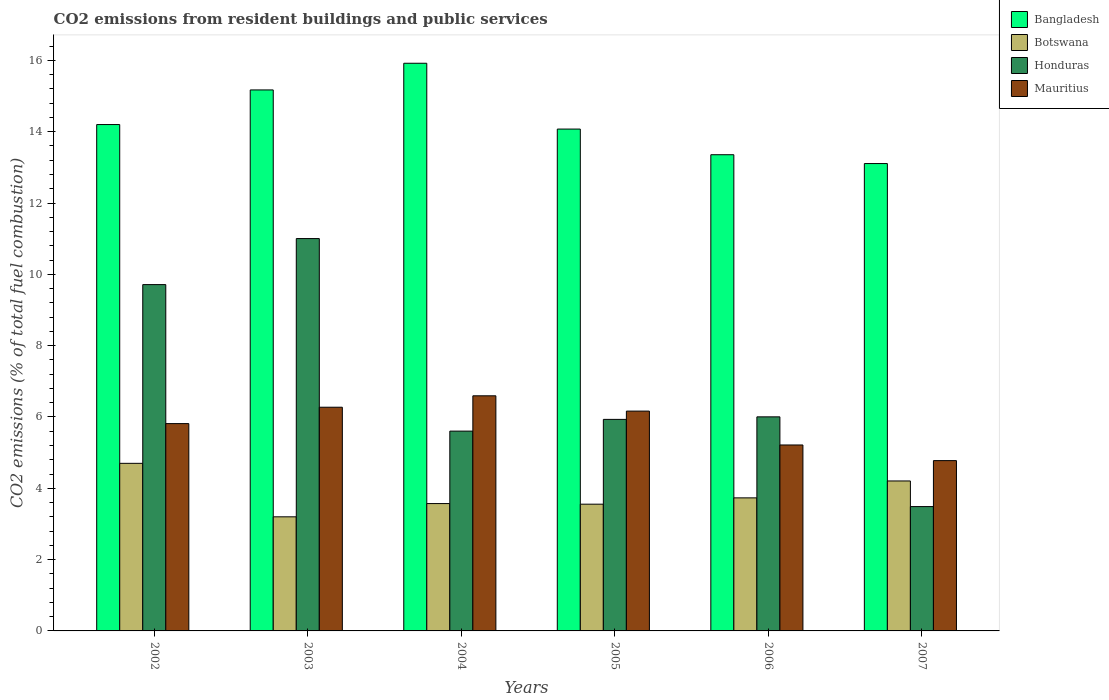How many different coloured bars are there?
Offer a very short reply. 4. How many groups of bars are there?
Provide a short and direct response. 6. How many bars are there on the 1st tick from the right?
Provide a succinct answer. 4. What is the label of the 4th group of bars from the left?
Keep it short and to the point. 2005. In how many cases, is the number of bars for a given year not equal to the number of legend labels?
Your response must be concise. 0. What is the total CO2 emitted in Mauritius in 2006?
Keep it short and to the point. 5.21. Across all years, what is the maximum total CO2 emitted in Mauritius?
Your answer should be compact. 6.59. Across all years, what is the minimum total CO2 emitted in Honduras?
Provide a short and direct response. 3.49. In which year was the total CO2 emitted in Bangladesh maximum?
Offer a very short reply. 2004. In which year was the total CO2 emitted in Botswana minimum?
Your answer should be compact. 2003. What is the total total CO2 emitted in Mauritius in the graph?
Make the answer very short. 34.84. What is the difference between the total CO2 emitted in Honduras in 2004 and that in 2007?
Offer a very short reply. 2.12. What is the difference between the total CO2 emitted in Mauritius in 2003 and the total CO2 emitted in Bangladesh in 2006?
Offer a very short reply. -7.08. What is the average total CO2 emitted in Botswana per year?
Your response must be concise. 3.83. In the year 2005, what is the difference between the total CO2 emitted in Mauritius and total CO2 emitted in Honduras?
Your answer should be very brief. 0.23. In how many years, is the total CO2 emitted in Botswana greater than 13.2?
Ensure brevity in your answer.  0. What is the ratio of the total CO2 emitted in Honduras in 2004 to that in 2005?
Provide a short and direct response. 0.94. Is the difference between the total CO2 emitted in Mauritius in 2004 and 2006 greater than the difference between the total CO2 emitted in Honduras in 2004 and 2006?
Provide a succinct answer. Yes. What is the difference between the highest and the second highest total CO2 emitted in Bangladesh?
Provide a succinct answer. 0.75. What is the difference between the highest and the lowest total CO2 emitted in Mauritius?
Your answer should be compact. 1.82. What does the 1st bar from the left in 2005 represents?
Ensure brevity in your answer.  Bangladesh. What does the 4th bar from the right in 2002 represents?
Provide a short and direct response. Bangladesh. How many bars are there?
Keep it short and to the point. 24. Are all the bars in the graph horizontal?
Offer a terse response. No. What is the difference between two consecutive major ticks on the Y-axis?
Ensure brevity in your answer.  2. Are the values on the major ticks of Y-axis written in scientific E-notation?
Keep it short and to the point. No. How are the legend labels stacked?
Make the answer very short. Vertical. What is the title of the graph?
Your answer should be compact. CO2 emissions from resident buildings and public services. What is the label or title of the X-axis?
Offer a terse response. Years. What is the label or title of the Y-axis?
Provide a short and direct response. CO2 emissions (% of total fuel combustion). What is the CO2 emissions (% of total fuel combustion) in Bangladesh in 2002?
Keep it short and to the point. 14.2. What is the CO2 emissions (% of total fuel combustion) in Botswana in 2002?
Your answer should be compact. 4.7. What is the CO2 emissions (% of total fuel combustion) in Honduras in 2002?
Provide a succinct answer. 9.71. What is the CO2 emissions (% of total fuel combustion) in Mauritius in 2002?
Your answer should be compact. 5.81. What is the CO2 emissions (% of total fuel combustion) of Bangladesh in 2003?
Give a very brief answer. 15.17. What is the CO2 emissions (% of total fuel combustion) of Honduras in 2003?
Provide a succinct answer. 11. What is the CO2 emissions (% of total fuel combustion) in Mauritius in 2003?
Offer a very short reply. 6.27. What is the CO2 emissions (% of total fuel combustion) in Bangladesh in 2004?
Your answer should be compact. 15.92. What is the CO2 emissions (% of total fuel combustion) in Botswana in 2004?
Make the answer very short. 3.57. What is the CO2 emissions (% of total fuel combustion) of Honduras in 2004?
Give a very brief answer. 5.6. What is the CO2 emissions (% of total fuel combustion) in Mauritius in 2004?
Offer a very short reply. 6.59. What is the CO2 emissions (% of total fuel combustion) in Bangladesh in 2005?
Offer a very short reply. 14.07. What is the CO2 emissions (% of total fuel combustion) in Botswana in 2005?
Your response must be concise. 3.55. What is the CO2 emissions (% of total fuel combustion) in Honduras in 2005?
Your answer should be compact. 5.93. What is the CO2 emissions (% of total fuel combustion) of Mauritius in 2005?
Your answer should be compact. 6.16. What is the CO2 emissions (% of total fuel combustion) of Bangladesh in 2006?
Your answer should be compact. 13.35. What is the CO2 emissions (% of total fuel combustion) in Botswana in 2006?
Your response must be concise. 3.73. What is the CO2 emissions (% of total fuel combustion) in Honduras in 2006?
Ensure brevity in your answer.  6. What is the CO2 emissions (% of total fuel combustion) in Mauritius in 2006?
Provide a succinct answer. 5.21. What is the CO2 emissions (% of total fuel combustion) of Bangladesh in 2007?
Your answer should be compact. 13.11. What is the CO2 emissions (% of total fuel combustion) of Botswana in 2007?
Your response must be concise. 4.21. What is the CO2 emissions (% of total fuel combustion) in Honduras in 2007?
Provide a succinct answer. 3.49. What is the CO2 emissions (% of total fuel combustion) of Mauritius in 2007?
Your response must be concise. 4.78. Across all years, what is the maximum CO2 emissions (% of total fuel combustion) of Bangladesh?
Make the answer very short. 15.92. Across all years, what is the maximum CO2 emissions (% of total fuel combustion) of Botswana?
Ensure brevity in your answer.  4.7. Across all years, what is the maximum CO2 emissions (% of total fuel combustion) of Honduras?
Your response must be concise. 11. Across all years, what is the maximum CO2 emissions (% of total fuel combustion) of Mauritius?
Ensure brevity in your answer.  6.59. Across all years, what is the minimum CO2 emissions (% of total fuel combustion) in Bangladesh?
Your answer should be compact. 13.11. Across all years, what is the minimum CO2 emissions (% of total fuel combustion) in Botswana?
Your answer should be compact. 3.2. Across all years, what is the minimum CO2 emissions (% of total fuel combustion) of Honduras?
Your answer should be very brief. 3.49. Across all years, what is the minimum CO2 emissions (% of total fuel combustion) of Mauritius?
Your response must be concise. 4.78. What is the total CO2 emissions (% of total fuel combustion) in Bangladesh in the graph?
Offer a very short reply. 85.83. What is the total CO2 emissions (% of total fuel combustion) in Botswana in the graph?
Give a very brief answer. 22.96. What is the total CO2 emissions (% of total fuel combustion) in Honduras in the graph?
Make the answer very short. 41.74. What is the total CO2 emissions (% of total fuel combustion) in Mauritius in the graph?
Ensure brevity in your answer.  34.84. What is the difference between the CO2 emissions (% of total fuel combustion) of Bangladesh in 2002 and that in 2003?
Your answer should be compact. -0.97. What is the difference between the CO2 emissions (% of total fuel combustion) in Botswana in 2002 and that in 2003?
Make the answer very short. 1.5. What is the difference between the CO2 emissions (% of total fuel combustion) in Honduras in 2002 and that in 2003?
Your answer should be very brief. -1.29. What is the difference between the CO2 emissions (% of total fuel combustion) in Mauritius in 2002 and that in 2003?
Your answer should be very brief. -0.46. What is the difference between the CO2 emissions (% of total fuel combustion) of Bangladesh in 2002 and that in 2004?
Keep it short and to the point. -1.72. What is the difference between the CO2 emissions (% of total fuel combustion) in Botswana in 2002 and that in 2004?
Your response must be concise. 1.13. What is the difference between the CO2 emissions (% of total fuel combustion) in Honduras in 2002 and that in 2004?
Your answer should be compact. 4.11. What is the difference between the CO2 emissions (% of total fuel combustion) in Mauritius in 2002 and that in 2004?
Ensure brevity in your answer.  -0.78. What is the difference between the CO2 emissions (% of total fuel combustion) in Bangladesh in 2002 and that in 2005?
Give a very brief answer. 0.13. What is the difference between the CO2 emissions (% of total fuel combustion) in Botswana in 2002 and that in 2005?
Your answer should be very brief. 1.15. What is the difference between the CO2 emissions (% of total fuel combustion) in Honduras in 2002 and that in 2005?
Make the answer very short. 3.78. What is the difference between the CO2 emissions (% of total fuel combustion) of Mauritius in 2002 and that in 2005?
Provide a succinct answer. -0.35. What is the difference between the CO2 emissions (% of total fuel combustion) of Bangladesh in 2002 and that in 2006?
Make the answer very short. 0.85. What is the difference between the CO2 emissions (% of total fuel combustion) of Botswana in 2002 and that in 2006?
Your answer should be very brief. 0.97. What is the difference between the CO2 emissions (% of total fuel combustion) of Honduras in 2002 and that in 2006?
Your answer should be very brief. 3.71. What is the difference between the CO2 emissions (% of total fuel combustion) of Mauritius in 2002 and that in 2006?
Offer a terse response. 0.6. What is the difference between the CO2 emissions (% of total fuel combustion) in Bangladesh in 2002 and that in 2007?
Ensure brevity in your answer.  1.09. What is the difference between the CO2 emissions (% of total fuel combustion) of Botswana in 2002 and that in 2007?
Offer a terse response. 0.49. What is the difference between the CO2 emissions (% of total fuel combustion) in Honduras in 2002 and that in 2007?
Keep it short and to the point. 6.23. What is the difference between the CO2 emissions (% of total fuel combustion) in Mauritius in 2002 and that in 2007?
Provide a succinct answer. 1.04. What is the difference between the CO2 emissions (% of total fuel combustion) of Bangladesh in 2003 and that in 2004?
Provide a short and direct response. -0.75. What is the difference between the CO2 emissions (% of total fuel combustion) of Botswana in 2003 and that in 2004?
Your answer should be very brief. -0.37. What is the difference between the CO2 emissions (% of total fuel combustion) in Honduras in 2003 and that in 2004?
Your response must be concise. 5.4. What is the difference between the CO2 emissions (% of total fuel combustion) in Mauritius in 2003 and that in 2004?
Keep it short and to the point. -0.32. What is the difference between the CO2 emissions (% of total fuel combustion) of Bangladesh in 2003 and that in 2005?
Your answer should be very brief. 1.1. What is the difference between the CO2 emissions (% of total fuel combustion) in Botswana in 2003 and that in 2005?
Ensure brevity in your answer.  -0.35. What is the difference between the CO2 emissions (% of total fuel combustion) in Honduras in 2003 and that in 2005?
Give a very brief answer. 5.07. What is the difference between the CO2 emissions (% of total fuel combustion) of Mauritius in 2003 and that in 2005?
Your answer should be very brief. 0.11. What is the difference between the CO2 emissions (% of total fuel combustion) in Bangladesh in 2003 and that in 2006?
Keep it short and to the point. 1.82. What is the difference between the CO2 emissions (% of total fuel combustion) of Botswana in 2003 and that in 2006?
Offer a terse response. -0.53. What is the difference between the CO2 emissions (% of total fuel combustion) in Honduras in 2003 and that in 2006?
Offer a terse response. 5. What is the difference between the CO2 emissions (% of total fuel combustion) of Mauritius in 2003 and that in 2006?
Your response must be concise. 1.06. What is the difference between the CO2 emissions (% of total fuel combustion) of Bangladesh in 2003 and that in 2007?
Provide a short and direct response. 2.06. What is the difference between the CO2 emissions (% of total fuel combustion) in Botswana in 2003 and that in 2007?
Offer a very short reply. -1.01. What is the difference between the CO2 emissions (% of total fuel combustion) of Honduras in 2003 and that in 2007?
Give a very brief answer. 7.52. What is the difference between the CO2 emissions (% of total fuel combustion) in Mauritius in 2003 and that in 2007?
Make the answer very short. 1.5. What is the difference between the CO2 emissions (% of total fuel combustion) of Bangladesh in 2004 and that in 2005?
Keep it short and to the point. 1.85. What is the difference between the CO2 emissions (% of total fuel combustion) in Botswana in 2004 and that in 2005?
Your answer should be compact. 0.02. What is the difference between the CO2 emissions (% of total fuel combustion) of Honduras in 2004 and that in 2005?
Offer a terse response. -0.33. What is the difference between the CO2 emissions (% of total fuel combustion) in Mauritius in 2004 and that in 2005?
Provide a short and direct response. 0.43. What is the difference between the CO2 emissions (% of total fuel combustion) in Bangladesh in 2004 and that in 2006?
Offer a terse response. 2.57. What is the difference between the CO2 emissions (% of total fuel combustion) of Botswana in 2004 and that in 2006?
Offer a terse response. -0.16. What is the difference between the CO2 emissions (% of total fuel combustion) of Honduras in 2004 and that in 2006?
Provide a short and direct response. -0.4. What is the difference between the CO2 emissions (% of total fuel combustion) in Mauritius in 2004 and that in 2006?
Offer a very short reply. 1.38. What is the difference between the CO2 emissions (% of total fuel combustion) in Bangladesh in 2004 and that in 2007?
Offer a very short reply. 2.81. What is the difference between the CO2 emissions (% of total fuel combustion) in Botswana in 2004 and that in 2007?
Ensure brevity in your answer.  -0.63. What is the difference between the CO2 emissions (% of total fuel combustion) of Honduras in 2004 and that in 2007?
Your answer should be very brief. 2.12. What is the difference between the CO2 emissions (% of total fuel combustion) of Mauritius in 2004 and that in 2007?
Give a very brief answer. 1.82. What is the difference between the CO2 emissions (% of total fuel combustion) in Bangladesh in 2005 and that in 2006?
Provide a succinct answer. 0.72. What is the difference between the CO2 emissions (% of total fuel combustion) of Botswana in 2005 and that in 2006?
Your answer should be compact. -0.18. What is the difference between the CO2 emissions (% of total fuel combustion) of Honduras in 2005 and that in 2006?
Your answer should be very brief. -0.07. What is the difference between the CO2 emissions (% of total fuel combustion) of Mauritius in 2005 and that in 2006?
Offer a very short reply. 0.95. What is the difference between the CO2 emissions (% of total fuel combustion) of Bangladesh in 2005 and that in 2007?
Provide a short and direct response. 0.97. What is the difference between the CO2 emissions (% of total fuel combustion) of Botswana in 2005 and that in 2007?
Make the answer very short. -0.65. What is the difference between the CO2 emissions (% of total fuel combustion) in Honduras in 2005 and that in 2007?
Give a very brief answer. 2.45. What is the difference between the CO2 emissions (% of total fuel combustion) in Mauritius in 2005 and that in 2007?
Keep it short and to the point. 1.39. What is the difference between the CO2 emissions (% of total fuel combustion) of Bangladesh in 2006 and that in 2007?
Provide a succinct answer. 0.25. What is the difference between the CO2 emissions (% of total fuel combustion) of Botswana in 2006 and that in 2007?
Provide a short and direct response. -0.47. What is the difference between the CO2 emissions (% of total fuel combustion) in Honduras in 2006 and that in 2007?
Ensure brevity in your answer.  2.52. What is the difference between the CO2 emissions (% of total fuel combustion) in Mauritius in 2006 and that in 2007?
Give a very brief answer. 0.44. What is the difference between the CO2 emissions (% of total fuel combustion) in Bangladesh in 2002 and the CO2 emissions (% of total fuel combustion) in Botswana in 2003?
Your answer should be very brief. 11. What is the difference between the CO2 emissions (% of total fuel combustion) in Bangladesh in 2002 and the CO2 emissions (% of total fuel combustion) in Honduras in 2003?
Your answer should be very brief. 3.2. What is the difference between the CO2 emissions (% of total fuel combustion) of Bangladesh in 2002 and the CO2 emissions (% of total fuel combustion) of Mauritius in 2003?
Ensure brevity in your answer.  7.93. What is the difference between the CO2 emissions (% of total fuel combustion) in Botswana in 2002 and the CO2 emissions (% of total fuel combustion) in Honduras in 2003?
Make the answer very short. -6.3. What is the difference between the CO2 emissions (% of total fuel combustion) in Botswana in 2002 and the CO2 emissions (% of total fuel combustion) in Mauritius in 2003?
Offer a terse response. -1.57. What is the difference between the CO2 emissions (% of total fuel combustion) of Honduras in 2002 and the CO2 emissions (% of total fuel combustion) of Mauritius in 2003?
Give a very brief answer. 3.44. What is the difference between the CO2 emissions (% of total fuel combustion) in Bangladesh in 2002 and the CO2 emissions (% of total fuel combustion) in Botswana in 2004?
Provide a succinct answer. 10.63. What is the difference between the CO2 emissions (% of total fuel combustion) of Bangladesh in 2002 and the CO2 emissions (% of total fuel combustion) of Honduras in 2004?
Ensure brevity in your answer.  8.6. What is the difference between the CO2 emissions (% of total fuel combustion) in Bangladesh in 2002 and the CO2 emissions (% of total fuel combustion) in Mauritius in 2004?
Offer a terse response. 7.61. What is the difference between the CO2 emissions (% of total fuel combustion) in Botswana in 2002 and the CO2 emissions (% of total fuel combustion) in Honduras in 2004?
Offer a terse response. -0.9. What is the difference between the CO2 emissions (% of total fuel combustion) of Botswana in 2002 and the CO2 emissions (% of total fuel combustion) of Mauritius in 2004?
Ensure brevity in your answer.  -1.89. What is the difference between the CO2 emissions (% of total fuel combustion) of Honduras in 2002 and the CO2 emissions (% of total fuel combustion) of Mauritius in 2004?
Offer a terse response. 3.12. What is the difference between the CO2 emissions (% of total fuel combustion) of Bangladesh in 2002 and the CO2 emissions (% of total fuel combustion) of Botswana in 2005?
Your answer should be very brief. 10.65. What is the difference between the CO2 emissions (% of total fuel combustion) in Bangladesh in 2002 and the CO2 emissions (% of total fuel combustion) in Honduras in 2005?
Your answer should be very brief. 8.27. What is the difference between the CO2 emissions (% of total fuel combustion) in Bangladesh in 2002 and the CO2 emissions (% of total fuel combustion) in Mauritius in 2005?
Your response must be concise. 8.04. What is the difference between the CO2 emissions (% of total fuel combustion) of Botswana in 2002 and the CO2 emissions (% of total fuel combustion) of Honduras in 2005?
Offer a very short reply. -1.23. What is the difference between the CO2 emissions (% of total fuel combustion) in Botswana in 2002 and the CO2 emissions (% of total fuel combustion) in Mauritius in 2005?
Give a very brief answer. -1.46. What is the difference between the CO2 emissions (% of total fuel combustion) in Honduras in 2002 and the CO2 emissions (% of total fuel combustion) in Mauritius in 2005?
Give a very brief answer. 3.55. What is the difference between the CO2 emissions (% of total fuel combustion) in Bangladesh in 2002 and the CO2 emissions (% of total fuel combustion) in Botswana in 2006?
Ensure brevity in your answer.  10.47. What is the difference between the CO2 emissions (% of total fuel combustion) of Bangladesh in 2002 and the CO2 emissions (% of total fuel combustion) of Honduras in 2006?
Offer a terse response. 8.2. What is the difference between the CO2 emissions (% of total fuel combustion) of Bangladesh in 2002 and the CO2 emissions (% of total fuel combustion) of Mauritius in 2006?
Make the answer very short. 8.99. What is the difference between the CO2 emissions (% of total fuel combustion) of Botswana in 2002 and the CO2 emissions (% of total fuel combustion) of Honduras in 2006?
Make the answer very short. -1.3. What is the difference between the CO2 emissions (% of total fuel combustion) in Botswana in 2002 and the CO2 emissions (% of total fuel combustion) in Mauritius in 2006?
Provide a succinct answer. -0.52. What is the difference between the CO2 emissions (% of total fuel combustion) in Honduras in 2002 and the CO2 emissions (% of total fuel combustion) in Mauritius in 2006?
Provide a succinct answer. 4.5. What is the difference between the CO2 emissions (% of total fuel combustion) in Bangladesh in 2002 and the CO2 emissions (% of total fuel combustion) in Botswana in 2007?
Your answer should be very brief. 9.99. What is the difference between the CO2 emissions (% of total fuel combustion) in Bangladesh in 2002 and the CO2 emissions (% of total fuel combustion) in Honduras in 2007?
Keep it short and to the point. 10.71. What is the difference between the CO2 emissions (% of total fuel combustion) in Bangladesh in 2002 and the CO2 emissions (% of total fuel combustion) in Mauritius in 2007?
Give a very brief answer. 9.42. What is the difference between the CO2 emissions (% of total fuel combustion) of Botswana in 2002 and the CO2 emissions (% of total fuel combustion) of Honduras in 2007?
Keep it short and to the point. 1.21. What is the difference between the CO2 emissions (% of total fuel combustion) of Botswana in 2002 and the CO2 emissions (% of total fuel combustion) of Mauritius in 2007?
Make the answer very short. -0.08. What is the difference between the CO2 emissions (% of total fuel combustion) in Honduras in 2002 and the CO2 emissions (% of total fuel combustion) in Mauritius in 2007?
Ensure brevity in your answer.  4.94. What is the difference between the CO2 emissions (% of total fuel combustion) in Bangladesh in 2003 and the CO2 emissions (% of total fuel combustion) in Botswana in 2004?
Your answer should be compact. 11.6. What is the difference between the CO2 emissions (% of total fuel combustion) in Bangladesh in 2003 and the CO2 emissions (% of total fuel combustion) in Honduras in 2004?
Offer a very short reply. 9.57. What is the difference between the CO2 emissions (% of total fuel combustion) in Bangladesh in 2003 and the CO2 emissions (% of total fuel combustion) in Mauritius in 2004?
Ensure brevity in your answer.  8.58. What is the difference between the CO2 emissions (% of total fuel combustion) of Botswana in 2003 and the CO2 emissions (% of total fuel combustion) of Honduras in 2004?
Provide a succinct answer. -2.4. What is the difference between the CO2 emissions (% of total fuel combustion) of Botswana in 2003 and the CO2 emissions (% of total fuel combustion) of Mauritius in 2004?
Provide a succinct answer. -3.39. What is the difference between the CO2 emissions (% of total fuel combustion) in Honduras in 2003 and the CO2 emissions (% of total fuel combustion) in Mauritius in 2004?
Your answer should be compact. 4.41. What is the difference between the CO2 emissions (% of total fuel combustion) of Bangladesh in 2003 and the CO2 emissions (% of total fuel combustion) of Botswana in 2005?
Keep it short and to the point. 11.62. What is the difference between the CO2 emissions (% of total fuel combustion) in Bangladesh in 2003 and the CO2 emissions (% of total fuel combustion) in Honduras in 2005?
Your answer should be compact. 9.24. What is the difference between the CO2 emissions (% of total fuel combustion) in Bangladesh in 2003 and the CO2 emissions (% of total fuel combustion) in Mauritius in 2005?
Make the answer very short. 9.01. What is the difference between the CO2 emissions (% of total fuel combustion) of Botswana in 2003 and the CO2 emissions (% of total fuel combustion) of Honduras in 2005?
Ensure brevity in your answer.  -2.73. What is the difference between the CO2 emissions (% of total fuel combustion) of Botswana in 2003 and the CO2 emissions (% of total fuel combustion) of Mauritius in 2005?
Your answer should be very brief. -2.96. What is the difference between the CO2 emissions (% of total fuel combustion) of Honduras in 2003 and the CO2 emissions (% of total fuel combustion) of Mauritius in 2005?
Provide a short and direct response. 4.84. What is the difference between the CO2 emissions (% of total fuel combustion) of Bangladesh in 2003 and the CO2 emissions (% of total fuel combustion) of Botswana in 2006?
Your response must be concise. 11.44. What is the difference between the CO2 emissions (% of total fuel combustion) of Bangladesh in 2003 and the CO2 emissions (% of total fuel combustion) of Honduras in 2006?
Your answer should be compact. 9.17. What is the difference between the CO2 emissions (% of total fuel combustion) of Bangladesh in 2003 and the CO2 emissions (% of total fuel combustion) of Mauritius in 2006?
Your answer should be very brief. 9.96. What is the difference between the CO2 emissions (% of total fuel combustion) in Botswana in 2003 and the CO2 emissions (% of total fuel combustion) in Honduras in 2006?
Make the answer very short. -2.8. What is the difference between the CO2 emissions (% of total fuel combustion) of Botswana in 2003 and the CO2 emissions (% of total fuel combustion) of Mauritius in 2006?
Give a very brief answer. -2.01. What is the difference between the CO2 emissions (% of total fuel combustion) in Honduras in 2003 and the CO2 emissions (% of total fuel combustion) in Mauritius in 2006?
Your answer should be very brief. 5.79. What is the difference between the CO2 emissions (% of total fuel combustion) in Bangladesh in 2003 and the CO2 emissions (% of total fuel combustion) in Botswana in 2007?
Provide a succinct answer. 10.97. What is the difference between the CO2 emissions (% of total fuel combustion) in Bangladesh in 2003 and the CO2 emissions (% of total fuel combustion) in Honduras in 2007?
Ensure brevity in your answer.  11.68. What is the difference between the CO2 emissions (% of total fuel combustion) of Bangladesh in 2003 and the CO2 emissions (% of total fuel combustion) of Mauritius in 2007?
Your response must be concise. 10.4. What is the difference between the CO2 emissions (% of total fuel combustion) of Botswana in 2003 and the CO2 emissions (% of total fuel combustion) of Honduras in 2007?
Offer a very short reply. -0.29. What is the difference between the CO2 emissions (% of total fuel combustion) in Botswana in 2003 and the CO2 emissions (% of total fuel combustion) in Mauritius in 2007?
Make the answer very short. -1.58. What is the difference between the CO2 emissions (% of total fuel combustion) in Honduras in 2003 and the CO2 emissions (% of total fuel combustion) in Mauritius in 2007?
Your answer should be compact. 6.23. What is the difference between the CO2 emissions (% of total fuel combustion) in Bangladesh in 2004 and the CO2 emissions (% of total fuel combustion) in Botswana in 2005?
Offer a very short reply. 12.37. What is the difference between the CO2 emissions (% of total fuel combustion) in Bangladesh in 2004 and the CO2 emissions (% of total fuel combustion) in Honduras in 2005?
Give a very brief answer. 9.99. What is the difference between the CO2 emissions (% of total fuel combustion) of Bangladesh in 2004 and the CO2 emissions (% of total fuel combustion) of Mauritius in 2005?
Give a very brief answer. 9.76. What is the difference between the CO2 emissions (% of total fuel combustion) in Botswana in 2004 and the CO2 emissions (% of total fuel combustion) in Honduras in 2005?
Make the answer very short. -2.36. What is the difference between the CO2 emissions (% of total fuel combustion) of Botswana in 2004 and the CO2 emissions (% of total fuel combustion) of Mauritius in 2005?
Your response must be concise. -2.59. What is the difference between the CO2 emissions (% of total fuel combustion) of Honduras in 2004 and the CO2 emissions (% of total fuel combustion) of Mauritius in 2005?
Give a very brief answer. -0.56. What is the difference between the CO2 emissions (% of total fuel combustion) of Bangladesh in 2004 and the CO2 emissions (% of total fuel combustion) of Botswana in 2006?
Provide a short and direct response. 12.19. What is the difference between the CO2 emissions (% of total fuel combustion) in Bangladesh in 2004 and the CO2 emissions (% of total fuel combustion) in Honduras in 2006?
Ensure brevity in your answer.  9.92. What is the difference between the CO2 emissions (% of total fuel combustion) of Bangladesh in 2004 and the CO2 emissions (% of total fuel combustion) of Mauritius in 2006?
Provide a short and direct response. 10.7. What is the difference between the CO2 emissions (% of total fuel combustion) of Botswana in 2004 and the CO2 emissions (% of total fuel combustion) of Honduras in 2006?
Provide a short and direct response. -2.43. What is the difference between the CO2 emissions (% of total fuel combustion) of Botswana in 2004 and the CO2 emissions (% of total fuel combustion) of Mauritius in 2006?
Your response must be concise. -1.64. What is the difference between the CO2 emissions (% of total fuel combustion) in Honduras in 2004 and the CO2 emissions (% of total fuel combustion) in Mauritius in 2006?
Provide a succinct answer. 0.39. What is the difference between the CO2 emissions (% of total fuel combustion) of Bangladesh in 2004 and the CO2 emissions (% of total fuel combustion) of Botswana in 2007?
Your answer should be very brief. 11.71. What is the difference between the CO2 emissions (% of total fuel combustion) of Bangladesh in 2004 and the CO2 emissions (% of total fuel combustion) of Honduras in 2007?
Keep it short and to the point. 12.43. What is the difference between the CO2 emissions (% of total fuel combustion) of Bangladesh in 2004 and the CO2 emissions (% of total fuel combustion) of Mauritius in 2007?
Provide a succinct answer. 11.14. What is the difference between the CO2 emissions (% of total fuel combustion) in Botswana in 2004 and the CO2 emissions (% of total fuel combustion) in Honduras in 2007?
Your answer should be compact. 0.08. What is the difference between the CO2 emissions (% of total fuel combustion) of Botswana in 2004 and the CO2 emissions (% of total fuel combustion) of Mauritius in 2007?
Your answer should be very brief. -1.2. What is the difference between the CO2 emissions (% of total fuel combustion) in Honduras in 2004 and the CO2 emissions (% of total fuel combustion) in Mauritius in 2007?
Provide a short and direct response. 0.83. What is the difference between the CO2 emissions (% of total fuel combustion) in Bangladesh in 2005 and the CO2 emissions (% of total fuel combustion) in Botswana in 2006?
Provide a succinct answer. 10.34. What is the difference between the CO2 emissions (% of total fuel combustion) in Bangladesh in 2005 and the CO2 emissions (% of total fuel combustion) in Honduras in 2006?
Your response must be concise. 8.07. What is the difference between the CO2 emissions (% of total fuel combustion) of Bangladesh in 2005 and the CO2 emissions (% of total fuel combustion) of Mauritius in 2006?
Provide a succinct answer. 8.86. What is the difference between the CO2 emissions (% of total fuel combustion) of Botswana in 2005 and the CO2 emissions (% of total fuel combustion) of Honduras in 2006?
Provide a short and direct response. -2.45. What is the difference between the CO2 emissions (% of total fuel combustion) in Botswana in 2005 and the CO2 emissions (% of total fuel combustion) in Mauritius in 2006?
Offer a very short reply. -1.66. What is the difference between the CO2 emissions (% of total fuel combustion) of Honduras in 2005 and the CO2 emissions (% of total fuel combustion) of Mauritius in 2006?
Ensure brevity in your answer.  0.72. What is the difference between the CO2 emissions (% of total fuel combustion) of Bangladesh in 2005 and the CO2 emissions (% of total fuel combustion) of Botswana in 2007?
Offer a terse response. 9.87. What is the difference between the CO2 emissions (% of total fuel combustion) of Bangladesh in 2005 and the CO2 emissions (% of total fuel combustion) of Honduras in 2007?
Offer a very short reply. 10.59. What is the difference between the CO2 emissions (% of total fuel combustion) in Bangladesh in 2005 and the CO2 emissions (% of total fuel combustion) in Mauritius in 2007?
Give a very brief answer. 9.3. What is the difference between the CO2 emissions (% of total fuel combustion) of Botswana in 2005 and the CO2 emissions (% of total fuel combustion) of Honduras in 2007?
Your answer should be very brief. 0.07. What is the difference between the CO2 emissions (% of total fuel combustion) of Botswana in 2005 and the CO2 emissions (% of total fuel combustion) of Mauritius in 2007?
Keep it short and to the point. -1.22. What is the difference between the CO2 emissions (% of total fuel combustion) in Honduras in 2005 and the CO2 emissions (% of total fuel combustion) in Mauritius in 2007?
Your response must be concise. 1.16. What is the difference between the CO2 emissions (% of total fuel combustion) of Bangladesh in 2006 and the CO2 emissions (% of total fuel combustion) of Botswana in 2007?
Your response must be concise. 9.15. What is the difference between the CO2 emissions (% of total fuel combustion) in Bangladesh in 2006 and the CO2 emissions (% of total fuel combustion) in Honduras in 2007?
Ensure brevity in your answer.  9.87. What is the difference between the CO2 emissions (% of total fuel combustion) in Bangladesh in 2006 and the CO2 emissions (% of total fuel combustion) in Mauritius in 2007?
Your answer should be compact. 8.58. What is the difference between the CO2 emissions (% of total fuel combustion) in Botswana in 2006 and the CO2 emissions (% of total fuel combustion) in Honduras in 2007?
Offer a terse response. 0.24. What is the difference between the CO2 emissions (% of total fuel combustion) of Botswana in 2006 and the CO2 emissions (% of total fuel combustion) of Mauritius in 2007?
Give a very brief answer. -1.04. What is the difference between the CO2 emissions (% of total fuel combustion) in Honduras in 2006 and the CO2 emissions (% of total fuel combustion) in Mauritius in 2007?
Make the answer very short. 1.23. What is the average CO2 emissions (% of total fuel combustion) of Bangladesh per year?
Make the answer very short. 14.3. What is the average CO2 emissions (% of total fuel combustion) in Botswana per year?
Provide a succinct answer. 3.83. What is the average CO2 emissions (% of total fuel combustion) in Honduras per year?
Offer a very short reply. 6.96. What is the average CO2 emissions (% of total fuel combustion) of Mauritius per year?
Ensure brevity in your answer.  5.81. In the year 2002, what is the difference between the CO2 emissions (% of total fuel combustion) in Bangladesh and CO2 emissions (% of total fuel combustion) in Botswana?
Ensure brevity in your answer.  9.5. In the year 2002, what is the difference between the CO2 emissions (% of total fuel combustion) of Bangladesh and CO2 emissions (% of total fuel combustion) of Honduras?
Your answer should be compact. 4.49. In the year 2002, what is the difference between the CO2 emissions (% of total fuel combustion) of Bangladesh and CO2 emissions (% of total fuel combustion) of Mauritius?
Offer a very short reply. 8.39. In the year 2002, what is the difference between the CO2 emissions (% of total fuel combustion) in Botswana and CO2 emissions (% of total fuel combustion) in Honduras?
Keep it short and to the point. -5.01. In the year 2002, what is the difference between the CO2 emissions (% of total fuel combustion) in Botswana and CO2 emissions (% of total fuel combustion) in Mauritius?
Give a very brief answer. -1.11. In the year 2002, what is the difference between the CO2 emissions (% of total fuel combustion) in Honduras and CO2 emissions (% of total fuel combustion) in Mauritius?
Make the answer very short. 3.9. In the year 2003, what is the difference between the CO2 emissions (% of total fuel combustion) in Bangladesh and CO2 emissions (% of total fuel combustion) in Botswana?
Offer a very short reply. 11.97. In the year 2003, what is the difference between the CO2 emissions (% of total fuel combustion) in Bangladesh and CO2 emissions (% of total fuel combustion) in Honduras?
Offer a very short reply. 4.17. In the year 2003, what is the difference between the CO2 emissions (% of total fuel combustion) in Bangladesh and CO2 emissions (% of total fuel combustion) in Mauritius?
Make the answer very short. 8.9. In the year 2003, what is the difference between the CO2 emissions (% of total fuel combustion) in Botswana and CO2 emissions (% of total fuel combustion) in Honduras?
Provide a short and direct response. -7.8. In the year 2003, what is the difference between the CO2 emissions (% of total fuel combustion) in Botswana and CO2 emissions (% of total fuel combustion) in Mauritius?
Your response must be concise. -3.07. In the year 2003, what is the difference between the CO2 emissions (% of total fuel combustion) of Honduras and CO2 emissions (% of total fuel combustion) of Mauritius?
Offer a very short reply. 4.73. In the year 2004, what is the difference between the CO2 emissions (% of total fuel combustion) of Bangladesh and CO2 emissions (% of total fuel combustion) of Botswana?
Your response must be concise. 12.35. In the year 2004, what is the difference between the CO2 emissions (% of total fuel combustion) of Bangladesh and CO2 emissions (% of total fuel combustion) of Honduras?
Provide a succinct answer. 10.32. In the year 2004, what is the difference between the CO2 emissions (% of total fuel combustion) of Bangladesh and CO2 emissions (% of total fuel combustion) of Mauritius?
Give a very brief answer. 9.33. In the year 2004, what is the difference between the CO2 emissions (% of total fuel combustion) of Botswana and CO2 emissions (% of total fuel combustion) of Honduras?
Ensure brevity in your answer.  -2.03. In the year 2004, what is the difference between the CO2 emissions (% of total fuel combustion) of Botswana and CO2 emissions (% of total fuel combustion) of Mauritius?
Provide a short and direct response. -3.02. In the year 2004, what is the difference between the CO2 emissions (% of total fuel combustion) in Honduras and CO2 emissions (% of total fuel combustion) in Mauritius?
Your answer should be very brief. -0.99. In the year 2005, what is the difference between the CO2 emissions (% of total fuel combustion) of Bangladesh and CO2 emissions (% of total fuel combustion) of Botswana?
Offer a terse response. 10.52. In the year 2005, what is the difference between the CO2 emissions (% of total fuel combustion) in Bangladesh and CO2 emissions (% of total fuel combustion) in Honduras?
Offer a terse response. 8.14. In the year 2005, what is the difference between the CO2 emissions (% of total fuel combustion) in Bangladesh and CO2 emissions (% of total fuel combustion) in Mauritius?
Your response must be concise. 7.91. In the year 2005, what is the difference between the CO2 emissions (% of total fuel combustion) of Botswana and CO2 emissions (% of total fuel combustion) of Honduras?
Provide a succinct answer. -2.38. In the year 2005, what is the difference between the CO2 emissions (% of total fuel combustion) in Botswana and CO2 emissions (% of total fuel combustion) in Mauritius?
Your answer should be compact. -2.61. In the year 2005, what is the difference between the CO2 emissions (% of total fuel combustion) in Honduras and CO2 emissions (% of total fuel combustion) in Mauritius?
Offer a very short reply. -0.23. In the year 2006, what is the difference between the CO2 emissions (% of total fuel combustion) of Bangladesh and CO2 emissions (% of total fuel combustion) of Botswana?
Ensure brevity in your answer.  9.62. In the year 2006, what is the difference between the CO2 emissions (% of total fuel combustion) of Bangladesh and CO2 emissions (% of total fuel combustion) of Honduras?
Ensure brevity in your answer.  7.35. In the year 2006, what is the difference between the CO2 emissions (% of total fuel combustion) in Bangladesh and CO2 emissions (% of total fuel combustion) in Mauritius?
Your answer should be compact. 8.14. In the year 2006, what is the difference between the CO2 emissions (% of total fuel combustion) in Botswana and CO2 emissions (% of total fuel combustion) in Honduras?
Your answer should be compact. -2.27. In the year 2006, what is the difference between the CO2 emissions (% of total fuel combustion) of Botswana and CO2 emissions (% of total fuel combustion) of Mauritius?
Your answer should be very brief. -1.48. In the year 2006, what is the difference between the CO2 emissions (% of total fuel combustion) in Honduras and CO2 emissions (% of total fuel combustion) in Mauritius?
Ensure brevity in your answer.  0.79. In the year 2007, what is the difference between the CO2 emissions (% of total fuel combustion) of Bangladesh and CO2 emissions (% of total fuel combustion) of Botswana?
Make the answer very short. 8.9. In the year 2007, what is the difference between the CO2 emissions (% of total fuel combustion) of Bangladesh and CO2 emissions (% of total fuel combustion) of Honduras?
Keep it short and to the point. 9.62. In the year 2007, what is the difference between the CO2 emissions (% of total fuel combustion) of Bangladesh and CO2 emissions (% of total fuel combustion) of Mauritius?
Your response must be concise. 8.33. In the year 2007, what is the difference between the CO2 emissions (% of total fuel combustion) of Botswana and CO2 emissions (% of total fuel combustion) of Honduras?
Offer a very short reply. 0.72. In the year 2007, what is the difference between the CO2 emissions (% of total fuel combustion) of Botswana and CO2 emissions (% of total fuel combustion) of Mauritius?
Provide a short and direct response. -0.57. In the year 2007, what is the difference between the CO2 emissions (% of total fuel combustion) in Honduras and CO2 emissions (% of total fuel combustion) in Mauritius?
Your answer should be compact. -1.29. What is the ratio of the CO2 emissions (% of total fuel combustion) in Bangladesh in 2002 to that in 2003?
Ensure brevity in your answer.  0.94. What is the ratio of the CO2 emissions (% of total fuel combustion) in Botswana in 2002 to that in 2003?
Provide a succinct answer. 1.47. What is the ratio of the CO2 emissions (% of total fuel combustion) in Honduras in 2002 to that in 2003?
Make the answer very short. 0.88. What is the ratio of the CO2 emissions (% of total fuel combustion) in Mauritius in 2002 to that in 2003?
Your answer should be very brief. 0.93. What is the ratio of the CO2 emissions (% of total fuel combustion) of Bangladesh in 2002 to that in 2004?
Provide a succinct answer. 0.89. What is the ratio of the CO2 emissions (% of total fuel combustion) in Botswana in 2002 to that in 2004?
Ensure brevity in your answer.  1.32. What is the ratio of the CO2 emissions (% of total fuel combustion) of Honduras in 2002 to that in 2004?
Your answer should be compact. 1.73. What is the ratio of the CO2 emissions (% of total fuel combustion) in Mauritius in 2002 to that in 2004?
Provide a succinct answer. 0.88. What is the ratio of the CO2 emissions (% of total fuel combustion) of Botswana in 2002 to that in 2005?
Offer a terse response. 1.32. What is the ratio of the CO2 emissions (% of total fuel combustion) in Honduras in 2002 to that in 2005?
Provide a succinct answer. 1.64. What is the ratio of the CO2 emissions (% of total fuel combustion) in Mauritius in 2002 to that in 2005?
Your answer should be compact. 0.94. What is the ratio of the CO2 emissions (% of total fuel combustion) in Bangladesh in 2002 to that in 2006?
Your answer should be compact. 1.06. What is the ratio of the CO2 emissions (% of total fuel combustion) of Botswana in 2002 to that in 2006?
Make the answer very short. 1.26. What is the ratio of the CO2 emissions (% of total fuel combustion) of Honduras in 2002 to that in 2006?
Your answer should be compact. 1.62. What is the ratio of the CO2 emissions (% of total fuel combustion) of Mauritius in 2002 to that in 2006?
Your answer should be compact. 1.11. What is the ratio of the CO2 emissions (% of total fuel combustion) in Bangladesh in 2002 to that in 2007?
Give a very brief answer. 1.08. What is the ratio of the CO2 emissions (% of total fuel combustion) in Botswana in 2002 to that in 2007?
Offer a terse response. 1.12. What is the ratio of the CO2 emissions (% of total fuel combustion) in Honduras in 2002 to that in 2007?
Make the answer very short. 2.79. What is the ratio of the CO2 emissions (% of total fuel combustion) of Mauritius in 2002 to that in 2007?
Your answer should be very brief. 1.22. What is the ratio of the CO2 emissions (% of total fuel combustion) in Bangladesh in 2003 to that in 2004?
Give a very brief answer. 0.95. What is the ratio of the CO2 emissions (% of total fuel combustion) of Botswana in 2003 to that in 2004?
Make the answer very short. 0.9. What is the ratio of the CO2 emissions (% of total fuel combustion) in Honduras in 2003 to that in 2004?
Offer a very short reply. 1.96. What is the ratio of the CO2 emissions (% of total fuel combustion) in Mauritius in 2003 to that in 2004?
Keep it short and to the point. 0.95. What is the ratio of the CO2 emissions (% of total fuel combustion) in Bangladesh in 2003 to that in 2005?
Make the answer very short. 1.08. What is the ratio of the CO2 emissions (% of total fuel combustion) of Botswana in 2003 to that in 2005?
Provide a short and direct response. 0.9. What is the ratio of the CO2 emissions (% of total fuel combustion) of Honduras in 2003 to that in 2005?
Make the answer very short. 1.85. What is the ratio of the CO2 emissions (% of total fuel combustion) in Mauritius in 2003 to that in 2005?
Provide a succinct answer. 1.02. What is the ratio of the CO2 emissions (% of total fuel combustion) of Bangladesh in 2003 to that in 2006?
Your response must be concise. 1.14. What is the ratio of the CO2 emissions (% of total fuel combustion) in Botswana in 2003 to that in 2006?
Provide a short and direct response. 0.86. What is the ratio of the CO2 emissions (% of total fuel combustion) of Honduras in 2003 to that in 2006?
Provide a short and direct response. 1.83. What is the ratio of the CO2 emissions (% of total fuel combustion) in Mauritius in 2003 to that in 2006?
Your answer should be very brief. 1.2. What is the ratio of the CO2 emissions (% of total fuel combustion) of Bangladesh in 2003 to that in 2007?
Provide a succinct answer. 1.16. What is the ratio of the CO2 emissions (% of total fuel combustion) of Botswana in 2003 to that in 2007?
Keep it short and to the point. 0.76. What is the ratio of the CO2 emissions (% of total fuel combustion) of Honduras in 2003 to that in 2007?
Give a very brief answer. 3.16. What is the ratio of the CO2 emissions (% of total fuel combustion) of Mauritius in 2003 to that in 2007?
Ensure brevity in your answer.  1.31. What is the ratio of the CO2 emissions (% of total fuel combustion) in Bangladesh in 2004 to that in 2005?
Your answer should be very brief. 1.13. What is the ratio of the CO2 emissions (% of total fuel combustion) of Botswana in 2004 to that in 2005?
Provide a short and direct response. 1. What is the ratio of the CO2 emissions (% of total fuel combustion) in Honduras in 2004 to that in 2005?
Offer a very short reply. 0.94. What is the ratio of the CO2 emissions (% of total fuel combustion) in Mauritius in 2004 to that in 2005?
Your response must be concise. 1.07. What is the ratio of the CO2 emissions (% of total fuel combustion) of Bangladesh in 2004 to that in 2006?
Provide a succinct answer. 1.19. What is the ratio of the CO2 emissions (% of total fuel combustion) of Botswana in 2004 to that in 2006?
Provide a short and direct response. 0.96. What is the ratio of the CO2 emissions (% of total fuel combustion) of Honduras in 2004 to that in 2006?
Give a very brief answer. 0.93. What is the ratio of the CO2 emissions (% of total fuel combustion) in Mauritius in 2004 to that in 2006?
Your response must be concise. 1.26. What is the ratio of the CO2 emissions (% of total fuel combustion) of Bangladesh in 2004 to that in 2007?
Make the answer very short. 1.21. What is the ratio of the CO2 emissions (% of total fuel combustion) of Botswana in 2004 to that in 2007?
Make the answer very short. 0.85. What is the ratio of the CO2 emissions (% of total fuel combustion) in Honduras in 2004 to that in 2007?
Provide a short and direct response. 1.61. What is the ratio of the CO2 emissions (% of total fuel combustion) in Mauritius in 2004 to that in 2007?
Ensure brevity in your answer.  1.38. What is the ratio of the CO2 emissions (% of total fuel combustion) in Bangladesh in 2005 to that in 2006?
Make the answer very short. 1.05. What is the ratio of the CO2 emissions (% of total fuel combustion) of Botswana in 2005 to that in 2006?
Make the answer very short. 0.95. What is the ratio of the CO2 emissions (% of total fuel combustion) of Mauritius in 2005 to that in 2006?
Offer a very short reply. 1.18. What is the ratio of the CO2 emissions (% of total fuel combustion) in Bangladesh in 2005 to that in 2007?
Provide a succinct answer. 1.07. What is the ratio of the CO2 emissions (% of total fuel combustion) in Botswana in 2005 to that in 2007?
Give a very brief answer. 0.85. What is the ratio of the CO2 emissions (% of total fuel combustion) of Honduras in 2005 to that in 2007?
Make the answer very short. 1.7. What is the ratio of the CO2 emissions (% of total fuel combustion) of Mauritius in 2005 to that in 2007?
Give a very brief answer. 1.29. What is the ratio of the CO2 emissions (% of total fuel combustion) of Bangladesh in 2006 to that in 2007?
Offer a very short reply. 1.02. What is the ratio of the CO2 emissions (% of total fuel combustion) of Botswana in 2006 to that in 2007?
Your answer should be very brief. 0.89. What is the ratio of the CO2 emissions (% of total fuel combustion) of Honduras in 2006 to that in 2007?
Your answer should be very brief. 1.72. What is the ratio of the CO2 emissions (% of total fuel combustion) of Mauritius in 2006 to that in 2007?
Make the answer very short. 1.09. What is the difference between the highest and the second highest CO2 emissions (% of total fuel combustion) of Bangladesh?
Make the answer very short. 0.75. What is the difference between the highest and the second highest CO2 emissions (% of total fuel combustion) of Botswana?
Give a very brief answer. 0.49. What is the difference between the highest and the second highest CO2 emissions (% of total fuel combustion) of Honduras?
Offer a terse response. 1.29. What is the difference between the highest and the second highest CO2 emissions (% of total fuel combustion) of Mauritius?
Your response must be concise. 0.32. What is the difference between the highest and the lowest CO2 emissions (% of total fuel combustion) in Bangladesh?
Keep it short and to the point. 2.81. What is the difference between the highest and the lowest CO2 emissions (% of total fuel combustion) of Botswana?
Provide a succinct answer. 1.5. What is the difference between the highest and the lowest CO2 emissions (% of total fuel combustion) in Honduras?
Give a very brief answer. 7.52. What is the difference between the highest and the lowest CO2 emissions (% of total fuel combustion) in Mauritius?
Ensure brevity in your answer.  1.82. 